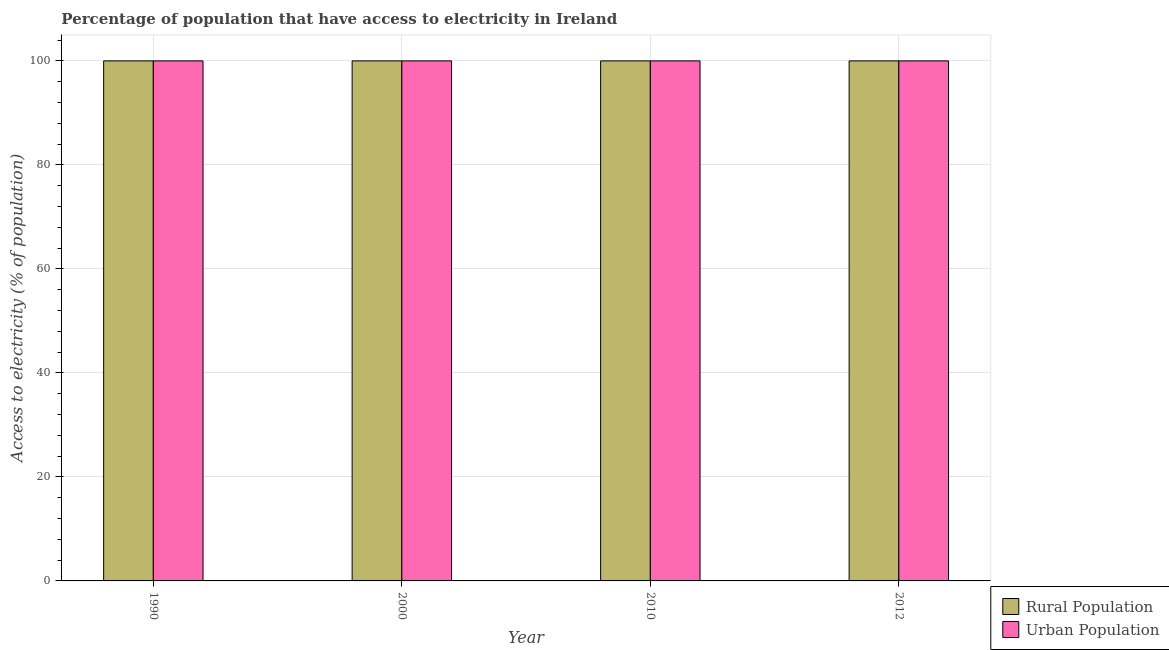Are the number of bars per tick equal to the number of legend labels?
Give a very brief answer. Yes. How many bars are there on the 3rd tick from the left?
Provide a short and direct response. 2. What is the percentage of rural population having access to electricity in 2000?
Offer a very short reply. 100. Across all years, what is the maximum percentage of rural population having access to electricity?
Your answer should be compact. 100. Across all years, what is the minimum percentage of urban population having access to electricity?
Ensure brevity in your answer.  100. In which year was the percentage of urban population having access to electricity maximum?
Your answer should be very brief. 1990. What is the total percentage of rural population having access to electricity in the graph?
Offer a terse response. 400. What is the difference between the percentage of urban population having access to electricity in 2000 and that in 2012?
Make the answer very short. 0. What is the difference between the percentage of urban population having access to electricity in 2000 and the percentage of rural population having access to electricity in 2012?
Offer a terse response. 0. In the year 2000, what is the difference between the percentage of rural population having access to electricity and percentage of urban population having access to electricity?
Provide a succinct answer. 0. In how many years, is the percentage of urban population having access to electricity greater than 60 %?
Ensure brevity in your answer.  4. What is the ratio of the percentage of urban population having access to electricity in 1990 to that in 2012?
Your answer should be very brief. 1. Is the percentage of rural population having access to electricity in 2010 less than that in 2012?
Your answer should be compact. No. Is the difference between the percentage of rural population having access to electricity in 1990 and 2010 greater than the difference between the percentage of urban population having access to electricity in 1990 and 2010?
Offer a very short reply. No. What is the difference between the highest and the lowest percentage of rural population having access to electricity?
Provide a short and direct response. 0. In how many years, is the percentage of urban population having access to electricity greater than the average percentage of urban population having access to electricity taken over all years?
Offer a very short reply. 0. Is the sum of the percentage of rural population having access to electricity in 2000 and 2012 greater than the maximum percentage of urban population having access to electricity across all years?
Offer a very short reply. Yes. What does the 1st bar from the left in 2000 represents?
Offer a very short reply. Rural Population. What does the 2nd bar from the right in 2012 represents?
Your response must be concise. Rural Population. Are the values on the major ticks of Y-axis written in scientific E-notation?
Offer a very short reply. No. Does the graph contain any zero values?
Offer a terse response. No. Does the graph contain grids?
Keep it short and to the point. Yes. Where does the legend appear in the graph?
Provide a succinct answer. Bottom right. How many legend labels are there?
Give a very brief answer. 2. What is the title of the graph?
Give a very brief answer. Percentage of population that have access to electricity in Ireland. What is the label or title of the X-axis?
Give a very brief answer. Year. What is the label or title of the Y-axis?
Offer a very short reply. Access to electricity (% of population). What is the Access to electricity (% of population) in Rural Population in 2000?
Your answer should be compact. 100. What is the Access to electricity (% of population) in Urban Population in 2010?
Provide a succinct answer. 100. Across all years, what is the maximum Access to electricity (% of population) of Urban Population?
Provide a succinct answer. 100. What is the total Access to electricity (% of population) of Rural Population in the graph?
Your response must be concise. 400. What is the total Access to electricity (% of population) in Urban Population in the graph?
Provide a short and direct response. 400. What is the difference between the Access to electricity (% of population) of Rural Population in 1990 and that in 2000?
Your answer should be compact. 0. What is the difference between the Access to electricity (% of population) of Urban Population in 1990 and that in 2010?
Your answer should be compact. 0. What is the difference between the Access to electricity (% of population) in Rural Population in 2000 and that in 2010?
Offer a very short reply. 0. What is the difference between the Access to electricity (% of population) of Rural Population in 2000 and that in 2012?
Give a very brief answer. 0. What is the difference between the Access to electricity (% of population) of Rural Population in 2000 and the Access to electricity (% of population) of Urban Population in 2010?
Ensure brevity in your answer.  0. What is the difference between the Access to electricity (% of population) of Rural Population in 2010 and the Access to electricity (% of population) of Urban Population in 2012?
Your response must be concise. 0. In the year 2012, what is the difference between the Access to electricity (% of population) of Rural Population and Access to electricity (% of population) of Urban Population?
Make the answer very short. 0. What is the ratio of the Access to electricity (% of population) of Urban Population in 1990 to that in 2000?
Offer a very short reply. 1. What is the ratio of the Access to electricity (% of population) in Rural Population in 1990 to that in 2010?
Make the answer very short. 1. What is the ratio of the Access to electricity (% of population) in Urban Population in 1990 to that in 2010?
Your response must be concise. 1. What is the ratio of the Access to electricity (% of population) of Rural Population in 1990 to that in 2012?
Give a very brief answer. 1. What is the ratio of the Access to electricity (% of population) in Urban Population in 1990 to that in 2012?
Offer a very short reply. 1. What is the ratio of the Access to electricity (% of population) of Urban Population in 2000 to that in 2010?
Your response must be concise. 1. What is the ratio of the Access to electricity (% of population) in Rural Population in 2000 to that in 2012?
Make the answer very short. 1. What is the ratio of the Access to electricity (% of population) of Urban Population in 2000 to that in 2012?
Offer a terse response. 1. What is the ratio of the Access to electricity (% of population) in Rural Population in 2010 to that in 2012?
Provide a short and direct response. 1. What is the difference between the highest and the second highest Access to electricity (% of population) of Rural Population?
Provide a short and direct response. 0. What is the difference between the highest and the second highest Access to electricity (% of population) of Urban Population?
Give a very brief answer. 0. What is the difference between the highest and the lowest Access to electricity (% of population) in Urban Population?
Keep it short and to the point. 0. 